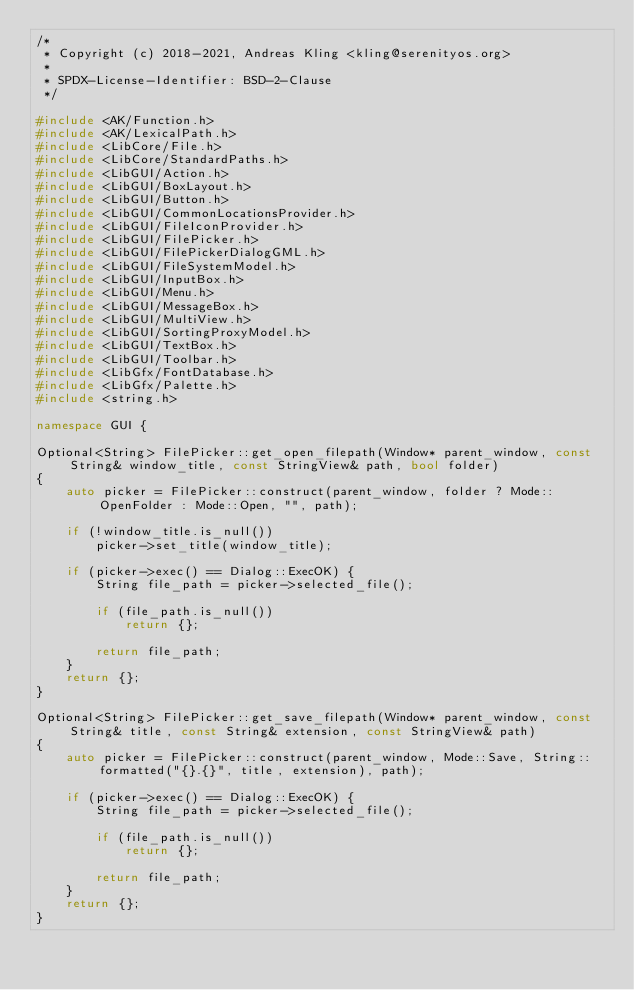<code> <loc_0><loc_0><loc_500><loc_500><_C++_>/*
 * Copyright (c) 2018-2021, Andreas Kling <kling@serenityos.org>
 *
 * SPDX-License-Identifier: BSD-2-Clause
 */

#include <AK/Function.h>
#include <AK/LexicalPath.h>
#include <LibCore/File.h>
#include <LibCore/StandardPaths.h>
#include <LibGUI/Action.h>
#include <LibGUI/BoxLayout.h>
#include <LibGUI/Button.h>
#include <LibGUI/CommonLocationsProvider.h>
#include <LibGUI/FileIconProvider.h>
#include <LibGUI/FilePicker.h>
#include <LibGUI/FilePickerDialogGML.h>
#include <LibGUI/FileSystemModel.h>
#include <LibGUI/InputBox.h>
#include <LibGUI/Menu.h>
#include <LibGUI/MessageBox.h>
#include <LibGUI/MultiView.h>
#include <LibGUI/SortingProxyModel.h>
#include <LibGUI/TextBox.h>
#include <LibGUI/Toolbar.h>
#include <LibGfx/FontDatabase.h>
#include <LibGfx/Palette.h>
#include <string.h>

namespace GUI {

Optional<String> FilePicker::get_open_filepath(Window* parent_window, const String& window_title, const StringView& path, bool folder)
{
    auto picker = FilePicker::construct(parent_window, folder ? Mode::OpenFolder : Mode::Open, "", path);

    if (!window_title.is_null())
        picker->set_title(window_title);

    if (picker->exec() == Dialog::ExecOK) {
        String file_path = picker->selected_file();

        if (file_path.is_null())
            return {};

        return file_path;
    }
    return {};
}

Optional<String> FilePicker::get_save_filepath(Window* parent_window, const String& title, const String& extension, const StringView& path)
{
    auto picker = FilePicker::construct(parent_window, Mode::Save, String::formatted("{}.{}", title, extension), path);

    if (picker->exec() == Dialog::ExecOK) {
        String file_path = picker->selected_file();

        if (file_path.is_null())
            return {};

        return file_path;
    }
    return {};
}
</code> 